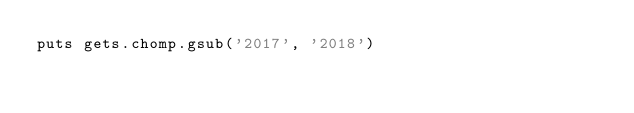Convert code to text. <code><loc_0><loc_0><loc_500><loc_500><_Ruby_>puts gets.chomp.gsub('2017', '2018')</code> 